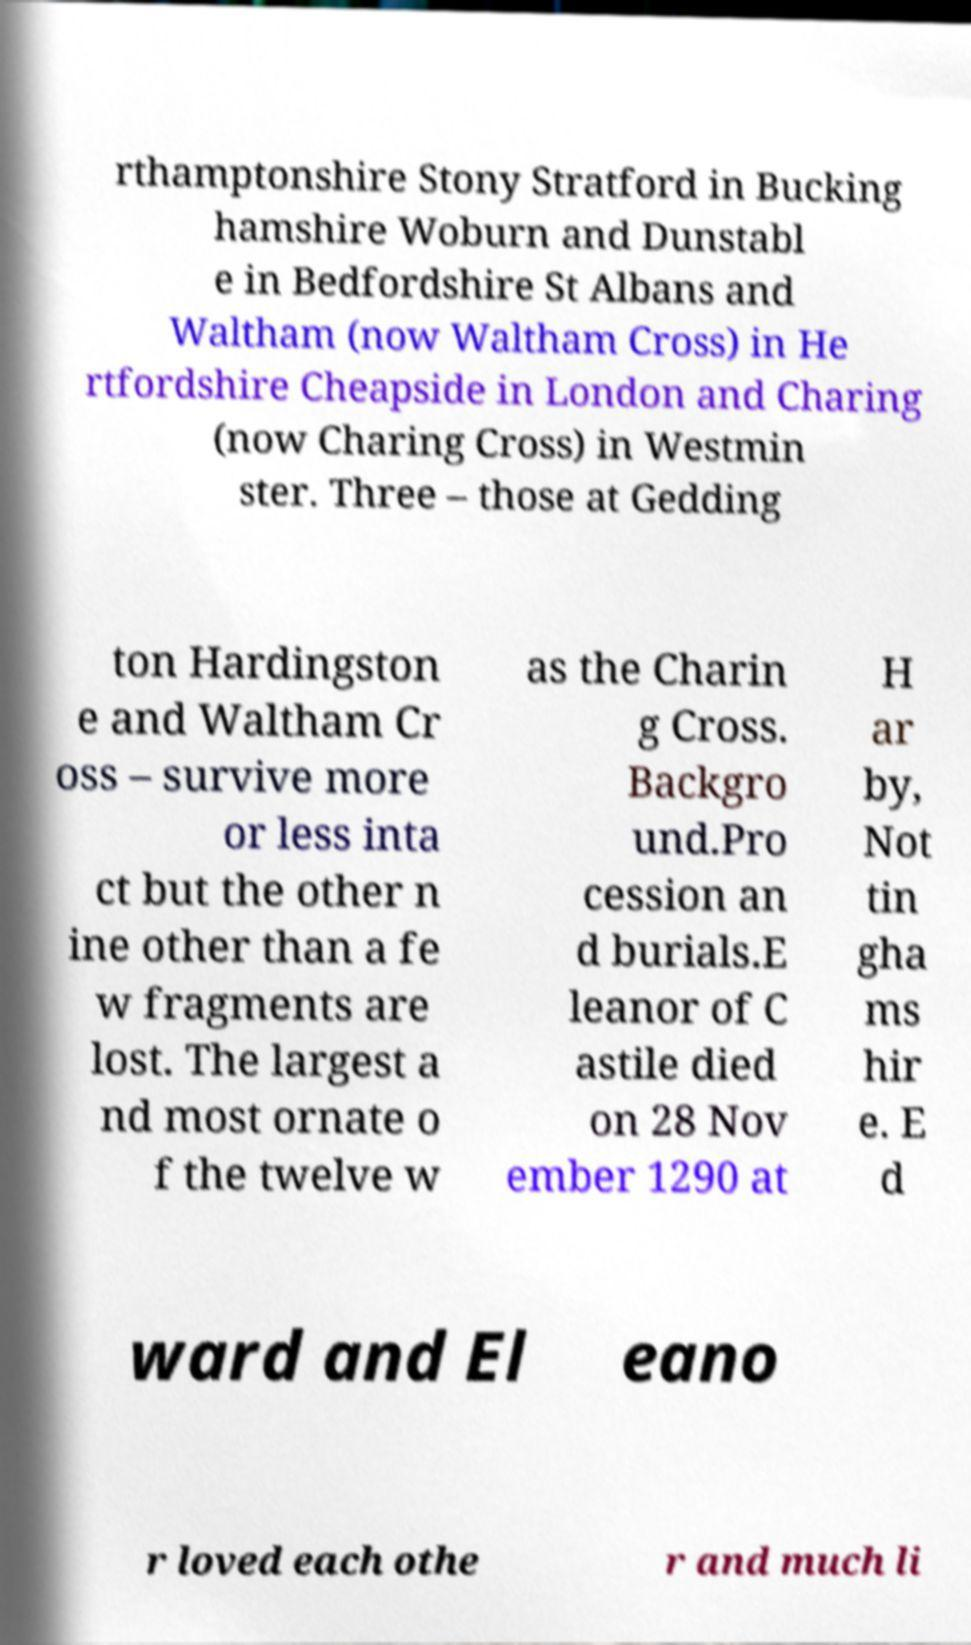Please read and relay the text visible in this image. What does it say? rthamptonshire Stony Stratford in Bucking hamshire Woburn and Dunstabl e in Bedfordshire St Albans and Waltham (now Waltham Cross) in He rtfordshire Cheapside in London and Charing (now Charing Cross) in Westmin ster. Three – those at Gedding ton Hardingston e and Waltham Cr oss – survive more or less inta ct but the other n ine other than a fe w fragments are lost. The largest a nd most ornate o f the twelve w as the Charin g Cross. Backgro und.Pro cession an d burials.E leanor of C astile died on 28 Nov ember 1290 at H ar by, Not tin gha ms hir e. E d ward and El eano r loved each othe r and much li 